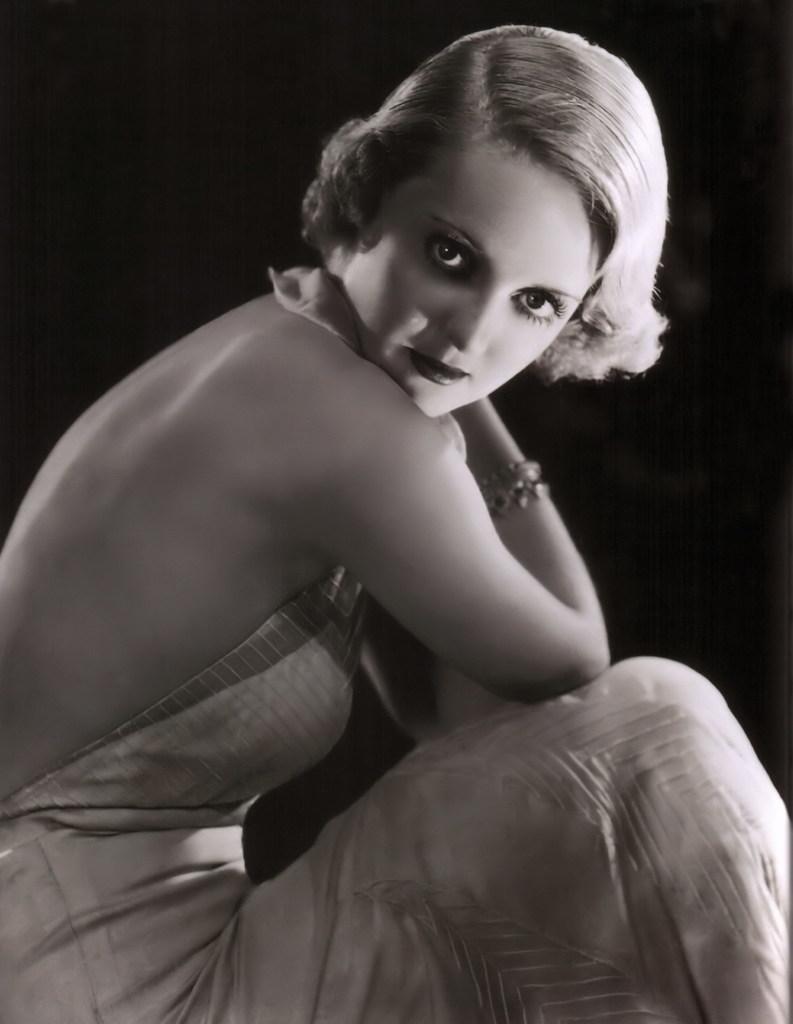Can you describe this image briefly? This is the black and white image of a woman. The background is black 